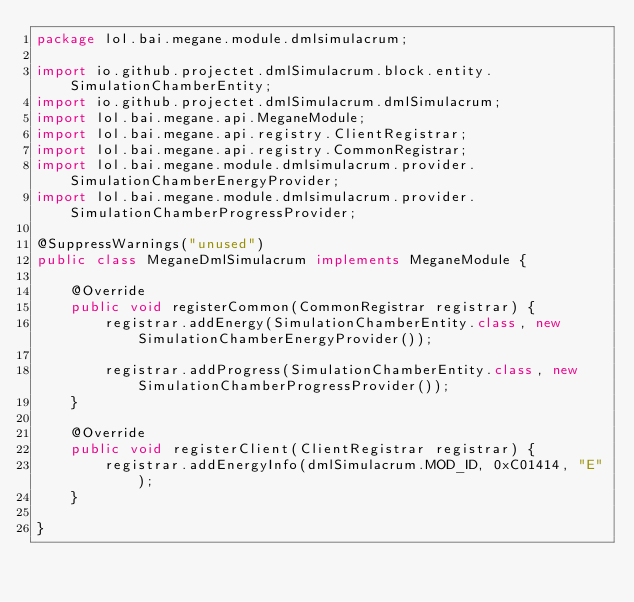<code> <loc_0><loc_0><loc_500><loc_500><_Java_>package lol.bai.megane.module.dmlsimulacrum;

import io.github.projectet.dmlSimulacrum.block.entity.SimulationChamberEntity;
import io.github.projectet.dmlSimulacrum.dmlSimulacrum;
import lol.bai.megane.api.MeganeModule;
import lol.bai.megane.api.registry.ClientRegistrar;
import lol.bai.megane.api.registry.CommonRegistrar;
import lol.bai.megane.module.dmlsimulacrum.provider.SimulationChamberEnergyProvider;
import lol.bai.megane.module.dmlsimulacrum.provider.SimulationChamberProgressProvider;

@SuppressWarnings("unused")
public class MeganeDmlSimulacrum implements MeganeModule {

    @Override
    public void registerCommon(CommonRegistrar registrar) {
        registrar.addEnergy(SimulationChamberEntity.class, new SimulationChamberEnergyProvider());

        registrar.addProgress(SimulationChamberEntity.class, new SimulationChamberProgressProvider());
    }

    @Override
    public void registerClient(ClientRegistrar registrar) {
        registrar.addEnergyInfo(dmlSimulacrum.MOD_ID, 0xC01414, "E");
    }

}
</code> 